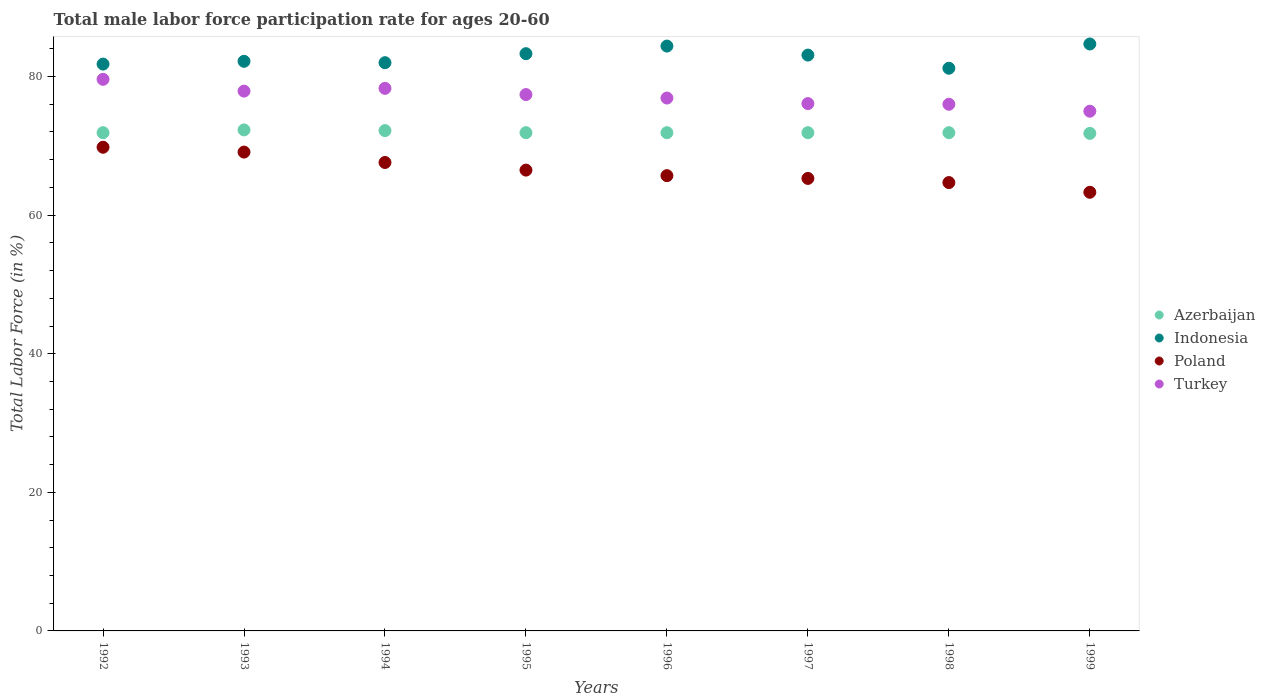What is the male labor force participation rate in Poland in 1994?
Provide a short and direct response. 67.6. Across all years, what is the maximum male labor force participation rate in Poland?
Provide a succinct answer. 69.8. Across all years, what is the minimum male labor force participation rate in Azerbaijan?
Your answer should be very brief. 71.8. In which year was the male labor force participation rate in Indonesia maximum?
Give a very brief answer. 1999. What is the total male labor force participation rate in Poland in the graph?
Ensure brevity in your answer.  532. What is the difference between the male labor force participation rate in Poland in 1994 and that in 1997?
Give a very brief answer. 2.3. What is the difference between the male labor force participation rate in Indonesia in 1997 and the male labor force participation rate in Poland in 1996?
Provide a succinct answer. 17.4. What is the average male labor force participation rate in Poland per year?
Provide a short and direct response. 66.5. In the year 1998, what is the difference between the male labor force participation rate in Indonesia and male labor force participation rate in Azerbaijan?
Your answer should be very brief. 9.3. What is the ratio of the male labor force participation rate in Turkey in 1994 to that in 1995?
Your answer should be compact. 1.01. Is the difference between the male labor force participation rate in Indonesia in 1994 and 1997 greater than the difference between the male labor force participation rate in Azerbaijan in 1994 and 1997?
Give a very brief answer. No. What is the difference between the highest and the second highest male labor force participation rate in Poland?
Make the answer very short. 0.7. What is the difference between the highest and the lowest male labor force participation rate in Poland?
Your answer should be very brief. 6.5. In how many years, is the male labor force participation rate in Poland greater than the average male labor force participation rate in Poland taken over all years?
Give a very brief answer. 4. Is the sum of the male labor force participation rate in Azerbaijan in 1994 and 1995 greater than the maximum male labor force participation rate in Indonesia across all years?
Provide a succinct answer. Yes. Is it the case that in every year, the sum of the male labor force participation rate in Indonesia and male labor force participation rate in Turkey  is greater than the male labor force participation rate in Poland?
Offer a terse response. Yes. Is the male labor force participation rate in Poland strictly less than the male labor force participation rate in Turkey over the years?
Give a very brief answer. Yes. How many dotlines are there?
Provide a succinct answer. 4. How many years are there in the graph?
Offer a terse response. 8. What is the difference between two consecutive major ticks on the Y-axis?
Keep it short and to the point. 20. Does the graph contain any zero values?
Provide a short and direct response. No. How are the legend labels stacked?
Offer a very short reply. Vertical. What is the title of the graph?
Offer a very short reply. Total male labor force participation rate for ages 20-60. What is the Total Labor Force (in %) in Azerbaijan in 1992?
Your response must be concise. 71.9. What is the Total Labor Force (in %) of Indonesia in 1992?
Provide a short and direct response. 81.8. What is the Total Labor Force (in %) in Poland in 1992?
Your answer should be very brief. 69.8. What is the Total Labor Force (in %) of Turkey in 1992?
Your answer should be compact. 79.6. What is the Total Labor Force (in %) in Azerbaijan in 1993?
Keep it short and to the point. 72.3. What is the Total Labor Force (in %) in Indonesia in 1993?
Your answer should be compact. 82.2. What is the Total Labor Force (in %) in Poland in 1993?
Ensure brevity in your answer.  69.1. What is the Total Labor Force (in %) of Turkey in 1993?
Provide a short and direct response. 77.9. What is the Total Labor Force (in %) in Azerbaijan in 1994?
Offer a terse response. 72.2. What is the Total Labor Force (in %) of Indonesia in 1994?
Offer a very short reply. 82. What is the Total Labor Force (in %) of Poland in 1994?
Provide a short and direct response. 67.6. What is the Total Labor Force (in %) in Turkey in 1994?
Offer a very short reply. 78.3. What is the Total Labor Force (in %) of Azerbaijan in 1995?
Offer a terse response. 71.9. What is the Total Labor Force (in %) in Indonesia in 1995?
Ensure brevity in your answer.  83.3. What is the Total Labor Force (in %) in Poland in 1995?
Your answer should be compact. 66.5. What is the Total Labor Force (in %) of Turkey in 1995?
Your answer should be very brief. 77.4. What is the Total Labor Force (in %) in Azerbaijan in 1996?
Offer a terse response. 71.9. What is the Total Labor Force (in %) of Indonesia in 1996?
Keep it short and to the point. 84.4. What is the Total Labor Force (in %) in Poland in 1996?
Keep it short and to the point. 65.7. What is the Total Labor Force (in %) in Turkey in 1996?
Ensure brevity in your answer.  76.9. What is the Total Labor Force (in %) in Azerbaijan in 1997?
Your answer should be very brief. 71.9. What is the Total Labor Force (in %) of Indonesia in 1997?
Keep it short and to the point. 83.1. What is the Total Labor Force (in %) of Poland in 1997?
Make the answer very short. 65.3. What is the Total Labor Force (in %) of Turkey in 1997?
Ensure brevity in your answer.  76.1. What is the Total Labor Force (in %) in Azerbaijan in 1998?
Make the answer very short. 71.9. What is the Total Labor Force (in %) of Indonesia in 1998?
Make the answer very short. 81.2. What is the Total Labor Force (in %) of Poland in 1998?
Ensure brevity in your answer.  64.7. What is the Total Labor Force (in %) of Turkey in 1998?
Offer a very short reply. 76. What is the Total Labor Force (in %) of Azerbaijan in 1999?
Make the answer very short. 71.8. What is the Total Labor Force (in %) of Indonesia in 1999?
Make the answer very short. 84.7. What is the Total Labor Force (in %) in Poland in 1999?
Make the answer very short. 63.3. Across all years, what is the maximum Total Labor Force (in %) in Azerbaijan?
Provide a short and direct response. 72.3. Across all years, what is the maximum Total Labor Force (in %) of Indonesia?
Make the answer very short. 84.7. Across all years, what is the maximum Total Labor Force (in %) of Poland?
Provide a succinct answer. 69.8. Across all years, what is the maximum Total Labor Force (in %) in Turkey?
Make the answer very short. 79.6. Across all years, what is the minimum Total Labor Force (in %) in Azerbaijan?
Provide a succinct answer. 71.8. Across all years, what is the minimum Total Labor Force (in %) of Indonesia?
Provide a succinct answer. 81.2. Across all years, what is the minimum Total Labor Force (in %) in Poland?
Provide a succinct answer. 63.3. What is the total Total Labor Force (in %) in Azerbaijan in the graph?
Ensure brevity in your answer.  575.8. What is the total Total Labor Force (in %) of Indonesia in the graph?
Keep it short and to the point. 662.7. What is the total Total Labor Force (in %) in Poland in the graph?
Provide a succinct answer. 532. What is the total Total Labor Force (in %) in Turkey in the graph?
Ensure brevity in your answer.  617.2. What is the difference between the Total Labor Force (in %) of Poland in 1992 and that in 1993?
Offer a very short reply. 0.7. What is the difference between the Total Labor Force (in %) in Turkey in 1992 and that in 1997?
Give a very brief answer. 3.5. What is the difference between the Total Labor Force (in %) of Azerbaijan in 1992 and that in 1998?
Your answer should be very brief. 0. What is the difference between the Total Labor Force (in %) in Poland in 1992 and that in 1998?
Offer a terse response. 5.1. What is the difference between the Total Labor Force (in %) of Azerbaijan in 1992 and that in 1999?
Make the answer very short. 0.1. What is the difference between the Total Labor Force (in %) in Indonesia in 1992 and that in 1999?
Your answer should be very brief. -2.9. What is the difference between the Total Labor Force (in %) of Poland in 1992 and that in 1999?
Give a very brief answer. 6.5. What is the difference between the Total Labor Force (in %) of Poland in 1993 and that in 1994?
Provide a short and direct response. 1.5. What is the difference between the Total Labor Force (in %) in Indonesia in 1993 and that in 1995?
Your answer should be compact. -1.1. What is the difference between the Total Labor Force (in %) of Indonesia in 1993 and that in 1996?
Your answer should be very brief. -2.2. What is the difference between the Total Labor Force (in %) in Poland in 1993 and that in 1996?
Ensure brevity in your answer.  3.4. What is the difference between the Total Labor Force (in %) in Turkey in 1993 and that in 1996?
Provide a succinct answer. 1. What is the difference between the Total Labor Force (in %) of Indonesia in 1993 and that in 1997?
Provide a short and direct response. -0.9. What is the difference between the Total Labor Force (in %) of Turkey in 1993 and that in 1997?
Offer a terse response. 1.8. What is the difference between the Total Labor Force (in %) in Indonesia in 1993 and that in 1998?
Provide a succinct answer. 1. What is the difference between the Total Labor Force (in %) of Poland in 1993 and that in 1998?
Your answer should be very brief. 4.4. What is the difference between the Total Labor Force (in %) of Turkey in 1993 and that in 1998?
Make the answer very short. 1.9. What is the difference between the Total Labor Force (in %) of Azerbaijan in 1993 and that in 1999?
Offer a terse response. 0.5. What is the difference between the Total Labor Force (in %) of Indonesia in 1993 and that in 1999?
Make the answer very short. -2.5. What is the difference between the Total Labor Force (in %) in Poland in 1993 and that in 1999?
Offer a terse response. 5.8. What is the difference between the Total Labor Force (in %) of Azerbaijan in 1994 and that in 1995?
Give a very brief answer. 0.3. What is the difference between the Total Labor Force (in %) of Indonesia in 1994 and that in 1995?
Provide a short and direct response. -1.3. What is the difference between the Total Labor Force (in %) in Turkey in 1994 and that in 1995?
Your answer should be compact. 0.9. What is the difference between the Total Labor Force (in %) of Azerbaijan in 1994 and that in 1996?
Provide a succinct answer. 0.3. What is the difference between the Total Labor Force (in %) in Poland in 1994 and that in 1996?
Provide a short and direct response. 1.9. What is the difference between the Total Labor Force (in %) in Azerbaijan in 1994 and that in 1997?
Keep it short and to the point. 0.3. What is the difference between the Total Labor Force (in %) of Poland in 1994 and that in 1997?
Make the answer very short. 2.3. What is the difference between the Total Labor Force (in %) in Turkey in 1994 and that in 1997?
Your answer should be compact. 2.2. What is the difference between the Total Labor Force (in %) of Azerbaijan in 1994 and that in 1998?
Provide a short and direct response. 0.3. What is the difference between the Total Labor Force (in %) in Poland in 1994 and that in 1998?
Provide a succinct answer. 2.9. What is the difference between the Total Labor Force (in %) of Indonesia in 1994 and that in 1999?
Give a very brief answer. -2.7. What is the difference between the Total Labor Force (in %) of Indonesia in 1995 and that in 1996?
Provide a short and direct response. -1.1. What is the difference between the Total Labor Force (in %) of Poland in 1995 and that in 1996?
Give a very brief answer. 0.8. What is the difference between the Total Labor Force (in %) in Turkey in 1995 and that in 1996?
Make the answer very short. 0.5. What is the difference between the Total Labor Force (in %) in Azerbaijan in 1995 and that in 1997?
Offer a very short reply. 0. What is the difference between the Total Labor Force (in %) in Indonesia in 1995 and that in 1997?
Your answer should be compact. 0.2. What is the difference between the Total Labor Force (in %) of Azerbaijan in 1995 and that in 1998?
Make the answer very short. 0. What is the difference between the Total Labor Force (in %) in Indonesia in 1995 and that in 1999?
Make the answer very short. -1.4. What is the difference between the Total Labor Force (in %) of Indonesia in 1996 and that in 1997?
Make the answer very short. 1.3. What is the difference between the Total Labor Force (in %) in Poland in 1996 and that in 1997?
Make the answer very short. 0.4. What is the difference between the Total Labor Force (in %) of Indonesia in 1996 and that in 1998?
Provide a short and direct response. 3.2. What is the difference between the Total Labor Force (in %) in Poland in 1996 and that in 1999?
Provide a succinct answer. 2.4. What is the difference between the Total Labor Force (in %) of Poland in 1997 and that in 1998?
Make the answer very short. 0.6. What is the difference between the Total Labor Force (in %) of Azerbaijan in 1997 and that in 1999?
Your answer should be very brief. 0.1. What is the difference between the Total Labor Force (in %) of Poland in 1997 and that in 1999?
Offer a very short reply. 2. What is the difference between the Total Labor Force (in %) in Turkey in 1997 and that in 1999?
Provide a succinct answer. 1.1. What is the difference between the Total Labor Force (in %) of Azerbaijan in 1998 and that in 1999?
Your answer should be very brief. 0.1. What is the difference between the Total Labor Force (in %) of Poland in 1998 and that in 1999?
Your response must be concise. 1.4. What is the difference between the Total Labor Force (in %) of Turkey in 1998 and that in 1999?
Make the answer very short. 1. What is the difference between the Total Labor Force (in %) in Azerbaijan in 1992 and the Total Labor Force (in %) in Indonesia in 1993?
Keep it short and to the point. -10.3. What is the difference between the Total Labor Force (in %) of Azerbaijan in 1992 and the Total Labor Force (in %) of Poland in 1993?
Offer a very short reply. 2.8. What is the difference between the Total Labor Force (in %) of Azerbaijan in 1992 and the Total Labor Force (in %) of Turkey in 1993?
Offer a very short reply. -6. What is the difference between the Total Labor Force (in %) of Indonesia in 1992 and the Total Labor Force (in %) of Turkey in 1994?
Make the answer very short. 3.5. What is the difference between the Total Labor Force (in %) of Poland in 1992 and the Total Labor Force (in %) of Turkey in 1994?
Offer a very short reply. -8.5. What is the difference between the Total Labor Force (in %) of Azerbaijan in 1992 and the Total Labor Force (in %) of Indonesia in 1995?
Your response must be concise. -11.4. What is the difference between the Total Labor Force (in %) of Azerbaijan in 1992 and the Total Labor Force (in %) of Poland in 1995?
Ensure brevity in your answer.  5.4. What is the difference between the Total Labor Force (in %) of Azerbaijan in 1992 and the Total Labor Force (in %) of Turkey in 1995?
Your answer should be compact. -5.5. What is the difference between the Total Labor Force (in %) in Indonesia in 1992 and the Total Labor Force (in %) in Poland in 1995?
Keep it short and to the point. 15.3. What is the difference between the Total Labor Force (in %) of Azerbaijan in 1992 and the Total Labor Force (in %) of Indonesia in 1996?
Your answer should be very brief. -12.5. What is the difference between the Total Labor Force (in %) of Azerbaijan in 1992 and the Total Labor Force (in %) of Turkey in 1996?
Give a very brief answer. -5. What is the difference between the Total Labor Force (in %) of Indonesia in 1992 and the Total Labor Force (in %) of Poland in 1996?
Give a very brief answer. 16.1. What is the difference between the Total Labor Force (in %) of Indonesia in 1992 and the Total Labor Force (in %) of Turkey in 1996?
Offer a very short reply. 4.9. What is the difference between the Total Labor Force (in %) in Poland in 1992 and the Total Labor Force (in %) in Turkey in 1996?
Offer a very short reply. -7.1. What is the difference between the Total Labor Force (in %) of Azerbaijan in 1992 and the Total Labor Force (in %) of Poland in 1997?
Make the answer very short. 6.6. What is the difference between the Total Labor Force (in %) of Azerbaijan in 1992 and the Total Labor Force (in %) of Indonesia in 1998?
Offer a terse response. -9.3. What is the difference between the Total Labor Force (in %) of Azerbaijan in 1992 and the Total Labor Force (in %) of Turkey in 1998?
Your answer should be compact. -4.1. What is the difference between the Total Labor Force (in %) of Indonesia in 1992 and the Total Labor Force (in %) of Turkey in 1998?
Provide a succinct answer. 5.8. What is the difference between the Total Labor Force (in %) of Poland in 1992 and the Total Labor Force (in %) of Turkey in 1998?
Give a very brief answer. -6.2. What is the difference between the Total Labor Force (in %) in Azerbaijan in 1992 and the Total Labor Force (in %) in Poland in 1999?
Keep it short and to the point. 8.6. What is the difference between the Total Labor Force (in %) in Azerbaijan in 1992 and the Total Labor Force (in %) in Turkey in 1999?
Ensure brevity in your answer.  -3.1. What is the difference between the Total Labor Force (in %) of Azerbaijan in 1993 and the Total Labor Force (in %) of Indonesia in 1994?
Your answer should be compact. -9.7. What is the difference between the Total Labor Force (in %) of Indonesia in 1993 and the Total Labor Force (in %) of Turkey in 1994?
Your response must be concise. 3.9. What is the difference between the Total Labor Force (in %) in Poland in 1993 and the Total Labor Force (in %) in Turkey in 1994?
Offer a terse response. -9.2. What is the difference between the Total Labor Force (in %) of Azerbaijan in 1993 and the Total Labor Force (in %) of Indonesia in 1995?
Ensure brevity in your answer.  -11. What is the difference between the Total Labor Force (in %) in Azerbaijan in 1993 and the Total Labor Force (in %) in Poland in 1995?
Your answer should be very brief. 5.8. What is the difference between the Total Labor Force (in %) of Poland in 1993 and the Total Labor Force (in %) of Turkey in 1995?
Ensure brevity in your answer.  -8.3. What is the difference between the Total Labor Force (in %) in Azerbaijan in 1993 and the Total Labor Force (in %) in Indonesia in 1996?
Keep it short and to the point. -12.1. What is the difference between the Total Labor Force (in %) of Azerbaijan in 1993 and the Total Labor Force (in %) of Turkey in 1996?
Offer a terse response. -4.6. What is the difference between the Total Labor Force (in %) of Poland in 1993 and the Total Labor Force (in %) of Turkey in 1996?
Give a very brief answer. -7.8. What is the difference between the Total Labor Force (in %) of Azerbaijan in 1993 and the Total Labor Force (in %) of Turkey in 1997?
Offer a very short reply. -3.8. What is the difference between the Total Labor Force (in %) of Indonesia in 1993 and the Total Labor Force (in %) of Poland in 1997?
Ensure brevity in your answer.  16.9. What is the difference between the Total Labor Force (in %) of Indonesia in 1993 and the Total Labor Force (in %) of Turkey in 1997?
Keep it short and to the point. 6.1. What is the difference between the Total Labor Force (in %) of Azerbaijan in 1993 and the Total Labor Force (in %) of Indonesia in 1998?
Give a very brief answer. -8.9. What is the difference between the Total Labor Force (in %) of Azerbaijan in 1993 and the Total Labor Force (in %) of Turkey in 1998?
Keep it short and to the point. -3.7. What is the difference between the Total Labor Force (in %) in Indonesia in 1993 and the Total Labor Force (in %) in Poland in 1998?
Make the answer very short. 17.5. What is the difference between the Total Labor Force (in %) in Poland in 1993 and the Total Labor Force (in %) in Turkey in 1998?
Your answer should be very brief. -6.9. What is the difference between the Total Labor Force (in %) of Azerbaijan in 1993 and the Total Labor Force (in %) of Poland in 1999?
Your answer should be compact. 9. What is the difference between the Total Labor Force (in %) in Azerbaijan in 1993 and the Total Labor Force (in %) in Turkey in 1999?
Offer a terse response. -2.7. What is the difference between the Total Labor Force (in %) in Indonesia in 1993 and the Total Labor Force (in %) in Turkey in 1999?
Keep it short and to the point. 7.2. What is the difference between the Total Labor Force (in %) in Azerbaijan in 1994 and the Total Labor Force (in %) in Indonesia in 1995?
Offer a terse response. -11.1. What is the difference between the Total Labor Force (in %) of Azerbaijan in 1994 and the Total Labor Force (in %) of Turkey in 1995?
Offer a very short reply. -5.2. What is the difference between the Total Labor Force (in %) of Indonesia in 1994 and the Total Labor Force (in %) of Poland in 1995?
Keep it short and to the point. 15.5. What is the difference between the Total Labor Force (in %) in Indonesia in 1994 and the Total Labor Force (in %) in Turkey in 1995?
Your response must be concise. 4.6. What is the difference between the Total Labor Force (in %) of Poland in 1994 and the Total Labor Force (in %) of Turkey in 1995?
Make the answer very short. -9.8. What is the difference between the Total Labor Force (in %) of Azerbaijan in 1994 and the Total Labor Force (in %) of Indonesia in 1996?
Your answer should be compact. -12.2. What is the difference between the Total Labor Force (in %) in Poland in 1994 and the Total Labor Force (in %) in Turkey in 1996?
Offer a terse response. -9.3. What is the difference between the Total Labor Force (in %) in Azerbaijan in 1994 and the Total Labor Force (in %) in Poland in 1997?
Make the answer very short. 6.9. What is the difference between the Total Labor Force (in %) of Azerbaijan in 1994 and the Total Labor Force (in %) of Indonesia in 1998?
Make the answer very short. -9. What is the difference between the Total Labor Force (in %) in Azerbaijan in 1994 and the Total Labor Force (in %) in Poland in 1998?
Provide a short and direct response. 7.5. What is the difference between the Total Labor Force (in %) in Azerbaijan in 1994 and the Total Labor Force (in %) in Turkey in 1998?
Provide a succinct answer. -3.8. What is the difference between the Total Labor Force (in %) in Indonesia in 1994 and the Total Labor Force (in %) in Turkey in 1998?
Your answer should be compact. 6. What is the difference between the Total Labor Force (in %) in Azerbaijan in 1994 and the Total Labor Force (in %) in Indonesia in 1999?
Give a very brief answer. -12.5. What is the difference between the Total Labor Force (in %) in Azerbaijan in 1994 and the Total Labor Force (in %) in Poland in 1999?
Keep it short and to the point. 8.9. What is the difference between the Total Labor Force (in %) of Azerbaijan in 1994 and the Total Labor Force (in %) of Turkey in 1999?
Give a very brief answer. -2.8. What is the difference between the Total Labor Force (in %) in Indonesia in 1994 and the Total Labor Force (in %) in Poland in 1999?
Provide a short and direct response. 18.7. What is the difference between the Total Labor Force (in %) in Indonesia in 1994 and the Total Labor Force (in %) in Turkey in 1999?
Your answer should be compact. 7. What is the difference between the Total Labor Force (in %) in Azerbaijan in 1995 and the Total Labor Force (in %) in Turkey in 1996?
Provide a succinct answer. -5. What is the difference between the Total Labor Force (in %) of Indonesia in 1995 and the Total Labor Force (in %) of Turkey in 1996?
Give a very brief answer. 6.4. What is the difference between the Total Labor Force (in %) in Azerbaijan in 1995 and the Total Labor Force (in %) in Turkey in 1997?
Make the answer very short. -4.2. What is the difference between the Total Labor Force (in %) in Indonesia in 1995 and the Total Labor Force (in %) in Poland in 1997?
Keep it short and to the point. 18. What is the difference between the Total Labor Force (in %) of Indonesia in 1995 and the Total Labor Force (in %) of Turkey in 1997?
Ensure brevity in your answer.  7.2. What is the difference between the Total Labor Force (in %) in Azerbaijan in 1995 and the Total Labor Force (in %) in Poland in 1998?
Make the answer very short. 7.2. What is the difference between the Total Labor Force (in %) of Azerbaijan in 1995 and the Total Labor Force (in %) of Poland in 1999?
Provide a short and direct response. 8.6. What is the difference between the Total Labor Force (in %) of Azerbaijan in 1995 and the Total Labor Force (in %) of Turkey in 1999?
Provide a short and direct response. -3.1. What is the difference between the Total Labor Force (in %) in Indonesia in 1995 and the Total Labor Force (in %) in Turkey in 1999?
Keep it short and to the point. 8.3. What is the difference between the Total Labor Force (in %) in Azerbaijan in 1996 and the Total Labor Force (in %) in Indonesia in 1997?
Make the answer very short. -11.2. What is the difference between the Total Labor Force (in %) of Azerbaijan in 1996 and the Total Labor Force (in %) of Poland in 1997?
Provide a short and direct response. 6.6. What is the difference between the Total Labor Force (in %) of Indonesia in 1996 and the Total Labor Force (in %) of Turkey in 1997?
Give a very brief answer. 8.3. What is the difference between the Total Labor Force (in %) of Poland in 1996 and the Total Labor Force (in %) of Turkey in 1997?
Provide a succinct answer. -10.4. What is the difference between the Total Labor Force (in %) in Azerbaijan in 1996 and the Total Labor Force (in %) in Indonesia in 1998?
Ensure brevity in your answer.  -9.3. What is the difference between the Total Labor Force (in %) in Indonesia in 1996 and the Total Labor Force (in %) in Poland in 1998?
Make the answer very short. 19.7. What is the difference between the Total Labor Force (in %) in Indonesia in 1996 and the Total Labor Force (in %) in Turkey in 1998?
Offer a very short reply. 8.4. What is the difference between the Total Labor Force (in %) in Poland in 1996 and the Total Labor Force (in %) in Turkey in 1998?
Make the answer very short. -10.3. What is the difference between the Total Labor Force (in %) of Azerbaijan in 1996 and the Total Labor Force (in %) of Poland in 1999?
Ensure brevity in your answer.  8.6. What is the difference between the Total Labor Force (in %) in Indonesia in 1996 and the Total Labor Force (in %) in Poland in 1999?
Your answer should be very brief. 21.1. What is the difference between the Total Labor Force (in %) in Indonesia in 1996 and the Total Labor Force (in %) in Turkey in 1999?
Make the answer very short. 9.4. What is the difference between the Total Labor Force (in %) in Azerbaijan in 1997 and the Total Labor Force (in %) in Poland in 1998?
Provide a short and direct response. 7.2. What is the difference between the Total Labor Force (in %) of Azerbaijan in 1997 and the Total Labor Force (in %) of Turkey in 1998?
Keep it short and to the point. -4.1. What is the difference between the Total Labor Force (in %) in Indonesia in 1997 and the Total Labor Force (in %) in Turkey in 1998?
Provide a succinct answer. 7.1. What is the difference between the Total Labor Force (in %) in Poland in 1997 and the Total Labor Force (in %) in Turkey in 1998?
Your response must be concise. -10.7. What is the difference between the Total Labor Force (in %) in Azerbaijan in 1997 and the Total Labor Force (in %) in Poland in 1999?
Ensure brevity in your answer.  8.6. What is the difference between the Total Labor Force (in %) of Indonesia in 1997 and the Total Labor Force (in %) of Poland in 1999?
Provide a succinct answer. 19.8. What is the difference between the Total Labor Force (in %) of Poland in 1997 and the Total Labor Force (in %) of Turkey in 1999?
Ensure brevity in your answer.  -9.7. What is the difference between the Total Labor Force (in %) of Indonesia in 1998 and the Total Labor Force (in %) of Turkey in 1999?
Keep it short and to the point. 6.2. What is the difference between the Total Labor Force (in %) in Poland in 1998 and the Total Labor Force (in %) in Turkey in 1999?
Your answer should be compact. -10.3. What is the average Total Labor Force (in %) in Azerbaijan per year?
Your answer should be very brief. 71.97. What is the average Total Labor Force (in %) of Indonesia per year?
Ensure brevity in your answer.  82.84. What is the average Total Labor Force (in %) in Poland per year?
Your answer should be compact. 66.5. What is the average Total Labor Force (in %) in Turkey per year?
Provide a short and direct response. 77.15. In the year 1992, what is the difference between the Total Labor Force (in %) of Azerbaijan and Total Labor Force (in %) of Indonesia?
Provide a succinct answer. -9.9. In the year 1992, what is the difference between the Total Labor Force (in %) of Azerbaijan and Total Labor Force (in %) of Turkey?
Offer a very short reply. -7.7. In the year 1992, what is the difference between the Total Labor Force (in %) in Indonesia and Total Labor Force (in %) in Turkey?
Keep it short and to the point. 2.2. In the year 1993, what is the difference between the Total Labor Force (in %) in Azerbaijan and Total Labor Force (in %) in Poland?
Give a very brief answer. 3.2. In the year 1993, what is the difference between the Total Labor Force (in %) of Azerbaijan and Total Labor Force (in %) of Turkey?
Make the answer very short. -5.6. In the year 1993, what is the difference between the Total Labor Force (in %) in Indonesia and Total Labor Force (in %) in Turkey?
Ensure brevity in your answer.  4.3. In the year 1994, what is the difference between the Total Labor Force (in %) in Azerbaijan and Total Labor Force (in %) in Turkey?
Provide a short and direct response. -6.1. In the year 1994, what is the difference between the Total Labor Force (in %) in Indonesia and Total Labor Force (in %) in Turkey?
Provide a succinct answer. 3.7. In the year 1994, what is the difference between the Total Labor Force (in %) in Poland and Total Labor Force (in %) in Turkey?
Ensure brevity in your answer.  -10.7. In the year 1995, what is the difference between the Total Labor Force (in %) of Indonesia and Total Labor Force (in %) of Poland?
Make the answer very short. 16.8. In the year 1996, what is the difference between the Total Labor Force (in %) in Azerbaijan and Total Labor Force (in %) in Indonesia?
Offer a terse response. -12.5. In the year 1996, what is the difference between the Total Labor Force (in %) of Azerbaijan and Total Labor Force (in %) of Poland?
Make the answer very short. 6.2. In the year 1996, what is the difference between the Total Labor Force (in %) of Poland and Total Labor Force (in %) of Turkey?
Provide a succinct answer. -11.2. In the year 1997, what is the difference between the Total Labor Force (in %) in Azerbaijan and Total Labor Force (in %) in Turkey?
Your answer should be compact. -4.2. In the year 1997, what is the difference between the Total Labor Force (in %) of Indonesia and Total Labor Force (in %) of Turkey?
Provide a short and direct response. 7. In the year 1997, what is the difference between the Total Labor Force (in %) in Poland and Total Labor Force (in %) in Turkey?
Offer a very short reply. -10.8. In the year 1998, what is the difference between the Total Labor Force (in %) in Azerbaijan and Total Labor Force (in %) in Indonesia?
Your response must be concise. -9.3. In the year 1998, what is the difference between the Total Labor Force (in %) in Azerbaijan and Total Labor Force (in %) in Turkey?
Ensure brevity in your answer.  -4.1. In the year 1998, what is the difference between the Total Labor Force (in %) in Poland and Total Labor Force (in %) in Turkey?
Keep it short and to the point. -11.3. In the year 1999, what is the difference between the Total Labor Force (in %) of Azerbaijan and Total Labor Force (in %) of Indonesia?
Provide a short and direct response. -12.9. In the year 1999, what is the difference between the Total Labor Force (in %) in Indonesia and Total Labor Force (in %) in Poland?
Provide a short and direct response. 21.4. In the year 1999, what is the difference between the Total Labor Force (in %) of Indonesia and Total Labor Force (in %) of Turkey?
Ensure brevity in your answer.  9.7. What is the ratio of the Total Labor Force (in %) in Turkey in 1992 to that in 1993?
Provide a short and direct response. 1.02. What is the ratio of the Total Labor Force (in %) in Poland in 1992 to that in 1994?
Your answer should be compact. 1.03. What is the ratio of the Total Labor Force (in %) in Turkey in 1992 to that in 1994?
Offer a very short reply. 1.02. What is the ratio of the Total Labor Force (in %) of Azerbaijan in 1992 to that in 1995?
Provide a short and direct response. 1. What is the ratio of the Total Labor Force (in %) in Indonesia in 1992 to that in 1995?
Offer a terse response. 0.98. What is the ratio of the Total Labor Force (in %) of Poland in 1992 to that in 1995?
Provide a succinct answer. 1.05. What is the ratio of the Total Labor Force (in %) of Turkey in 1992 to that in 1995?
Your answer should be very brief. 1.03. What is the ratio of the Total Labor Force (in %) in Indonesia in 1992 to that in 1996?
Provide a short and direct response. 0.97. What is the ratio of the Total Labor Force (in %) of Poland in 1992 to that in 1996?
Give a very brief answer. 1.06. What is the ratio of the Total Labor Force (in %) of Turkey in 1992 to that in 1996?
Your answer should be compact. 1.04. What is the ratio of the Total Labor Force (in %) in Indonesia in 1992 to that in 1997?
Give a very brief answer. 0.98. What is the ratio of the Total Labor Force (in %) in Poland in 1992 to that in 1997?
Your response must be concise. 1.07. What is the ratio of the Total Labor Force (in %) in Turkey in 1992 to that in 1997?
Make the answer very short. 1.05. What is the ratio of the Total Labor Force (in %) in Azerbaijan in 1992 to that in 1998?
Give a very brief answer. 1. What is the ratio of the Total Labor Force (in %) of Indonesia in 1992 to that in 1998?
Your answer should be compact. 1.01. What is the ratio of the Total Labor Force (in %) of Poland in 1992 to that in 1998?
Give a very brief answer. 1.08. What is the ratio of the Total Labor Force (in %) of Turkey in 1992 to that in 1998?
Your answer should be compact. 1.05. What is the ratio of the Total Labor Force (in %) of Indonesia in 1992 to that in 1999?
Make the answer very short. 0.97. What is the ratio of the Total Labor Force (in %) in Poland in 1992 to that in 1999?
Keep it short and to the point. 1.1. What is the ratio of the Total Labor Force (in %) of Turkey in 1992 to that in 1999?
Make the answer very short. 1.06. What is the ratio of the Total Labor Force (in %) of Indonesia in 1993 to that in 1994?
Offer a very short reply. 1. What is the ratio of the Total Labor Force (in %) in Poland in 1993 to that in 1994?
Ensure brevity in your answer.  1.02. What is the ratio of the Total Labor Force (in %) in Turkey in 1993 to that in 1994?
Keep it short and to the point. 0.99. What is the ratio of the Total Labor Force (in %) of Azerbaijan in 1993 to that in 1995?
Keep it short and to the point. 1.01. What is the ratio of the Total Labor Force (in %) in Indonesia in 1993 to that in 1995?
Provide a short and direct response. 0.99. What is the ratio of the Total Labor Force (in %) in Poland in 1993 to that in 1995?
Provide a short and direct response. 1.04. What is the ratio of the Total Labor Force (in %) in Azerbaijan in 1993 to that in 1996?
Your answer should be very brief. 1.01. What is the ratio of the Total Labor Force (in %) of Indonesia in 1993 to that in 1996?
Your answer should be very brief. 0.97. What is the ratio of the Total Labor Force (in %) in Poland in 1993 to that in 1996?
Keep it short and to the point. 1.05. What is the ratio of the Total Labor Force (in %) of Azerbaijan in 1993 to that in 1997?
Provide a short and direct response. 1.01. What is the ratio of the Total Labor Force (in %) in Poland in 1993 to that in 1997?
Your answer should be very brief. 1.06. What is the ratio of the Total Labor Force (in %) in Turkey in 1993 to that in 1997?
Ensure brevity in your answer.  1.02. What is the ratio of the Total Labor Force (in %) of Azerbaijan in 1993 to that in 1998?
Your response must be concise. 1.01. What is the ratio of the Total Labor Force (in %) in Indonesia in 1993 to that in 1998?
Keep it short and to the point. 1.01. What is the ratio of the Total Labor Force (in %) of Poland in 1993 to that in 1998?
Give a very brief answer. 1.07. What is the ratio of the Total Labor Force (in %) in Turkey in 1993 to that in 1998?
Keep it short and to the point. 1.02. What is the ratio of the Total Labor Force (in %) in Azerbaijan in 1993 to that in 1999?
Your response must be concise. 1.01. What is the ratio of the Total Labor Force (in %) in Indonesia in 1993 to that in 1999?
Your answer should be compact. 0.97. What is the ratio of the Total Labor Force (in %) of Poland in 1993 to that in 1999?
Your answer should be very brief. 1.09. What is the ratio of the Total Labor Force (in %) in Turkey in 1993 to that in 1999?
Your response must be concise. 1.04. What is the ratio of the Total Labor Force (in %) of Indonesia in 1994 to that in 1995?
Provide a short and direct response. 0.98. What is the ratio of the Total Labor Force (in %) in Poland in 1994 to that in 1995?
Provide a succinct answer. 1.02. What is the ratio of the Total Labor Force (in %) in Turkey in 1994 to that in 1995?
Provide a short and direct response. 1.01. What is the ratio of the Total Labor Force (in %) of Azerbaijan in 1994 to that in 1996?
Your answer should be compact. 1. What is the ratio of the Total Labor Force (in %) of Indonesia in 1994 to that in 1996?
Your answer should be compact. 0.97. What is the ratio of the Total Labor Force (in %) of Poland in 1994 to that in 1996?
Your answer should be very brief. 1.03. What is the ratio of the Total Labor Force (in %) in Turkey in 1994 to that in 1996?
Your answer should be compact. 1.02. What is the ratio of the Total Labor Force (in %) of Azerbaijan in 1994 to that in 1997?
Offer a terse response. 1. What is the ratio of the Total Labor Force (in %) in Indonesia in 1994 to that in 1997?
Make the answer very short. 0.99. What is the ratio of the Total Labor Force (in %) of Poland in 1994 to that in 1997?
Make the answer very short. 1.04. What is the ratio of the Total Labor Force (in %) in Turkey in 1994 to that in 1997?
Keep it short and to the point. 1.03. What is the ratio of the Total Labor Force (in %) in Azerbaijan in 1994 to that in 1998?
Ensure brevity in your answer.  1. What is the ratio of the Total Labor Force (in %) of Indonesia in 1994 to that in 1998?
Provide a succinct answer. 1.01. What is the ratio of the Total Labor Force (in %) in Poland in 1994 to that in 1998?
Provide a short and direct response. 1.04. What is the ratio of the Total Labor Force (in %) in Turkey in 1994 to that in 1998?
Your response must be concise. 1.03. What is the ratio of the Total Labor Force (in %) in Azerbaijan in 1994 to that in 1999?
Offer a very short reply. 1.01. What is the ratio of the Total Labor Force (in %) of Indonesia in 1994 to that in 1999?
Give a very brief answer. 0.97. What is the ratio of the Total Labor Force (in %) of Poland in 1994 to that in 1999?
Provide a short and direct response. 1.07. What is the ratio of the Total Labor Force (in %) in Turkey in 1994 to that in 1999?
Keep it short and to the point. 1.04. What is the ratio of the Total Labor Force (in %) of Indonesia in 1995 to that in 1996?
Give a very brief answer. 0.99. What is the ratio of the Total Labor Force (in %) in Poland in 1995 to that in 1996?
Offer a very short reply. 1.01. What is the ratio of the Total Labor Force (in %) of Indonesia in 1995 to that in 1997?
Make the answer very short. 1. What is the ratio of the Total Labor Force (in %) of Poland in 1995 to that in 1997?
Provide a short and direct response. 1.02. What is the ratio of the Total Labor Force (in %) of Turkey in 1995 to that in 1997?
Offer a terse response. 1.02. What is the ratio of the Total Labor Force (in %) in Azerbaijan in 1995 to that in 1998?
Keep it short and to the point. 1. What is the ratio of the Total Labor Force (in %) of Indonesia in 1995 to that in 1998?
Offer a very short reply. 1.03. What is the ratio of the Total Labor Force (in %) of Poland in 1995 to that in 1998?
Your response must be concise. 1.03. What is the ratio of the Total Labor Force (in %) of Turkey in 1995 to that in 1998?
Your answer should be compact. 1.02. What is the ratio of the Total Labor Force (in %) of Azerbaijan in 1995 to that in 1999?
Your answer should be very brief. 1. What is the ratio of the Total Labor Force (in %) of Indonesia in 1995 to that in 1999?
Offer a very short reply. 0.98. What is the ratio of the Total Labor Force (in %) of Poland in 1995 to that in 1999?
Give a very brief answer. 1.05. What is the ratio of the Total Labor Force (in %) of Turkey in 1995 to that in 1999?
Provide a short and direct response. 1.03. What is the ratio of the Total Labor Force (in %) in Indonesia in 1996 to that in 1997?
Ensure brevity in your answer.  1.02. What is the ratio of the Total Labor Force (in %) in Poland in 1996 to that in 1997?
Keep it short and to the point. 1.01. What is the ratio of the Total Labor Force (in %) in Turkey in 1996 to that in 1997?
Your response must be concise. 1.01. What is the ratio of the Total Labor Force (in %) in Azerbaijan in 1996 to that in 1998?
Provide a succinct answer. 1. What is the ratio of the Total Labor Force (in %) of Indonesia in 1996 to that in 1998?
Your answer should be compact. 1.04. What is the ratio of the Total Labor Force (in %) in Poland in 1996 to that in 1998?
Provide a succinct answer. 1.02. What is the ratio of the Total Labor Force (in %) in Turkey in 1996 to that in 1998?
Your answer should be very brief. 1.01. What is the ratio of the Total Labor Force (in %) in Azerbaijan in 1996 to that in 1999?
Your answer should be compact. 1. What is the ratio of the Total Labor Force (in %) in Poland in 1996 to that in 1999?
Provide a succinct answer. 1.04. What is the ratio of the Total Labor Force (in %) of Turkey in 1996 to that in 1999?
Provide a succinct answer. 1.03. What is the ratio of the Total Labor Force (in %) of Indonesia in 1997 to that in 1998?
Ensure brevity in your answer.  1.02. What is the ratio of the Total Labor Force (in %) of Poland in 1997 to that in 1998?
Provide a short and direct response. 1.01. What is the ratio of the Total Labor Force (in %) of Turkey in 1997 to that in 1998?
Offer a very short reply. 1. What is the ratio of the Total Labor Force (in %) of Indonesia in 1997 to that in 1999?
Give a very brief answer. 0.98. What is the ratio of the Total Labor Force (in %) of Poland in 1997 to that in 1999?
Keep it short and to the point. 1.03. What is the ratio of the Total Labor Force (in %) in Turkey in 1997 to that in 1999?
Your answer should be very brief. 1.01. What is the ratio of the Total Labor Force (in %) of Azerbaijan in 1998 to that in 1999?
Provide a short and direct response. 1. What is the ratio of the Total Labor Force (in %) of Indonesia in 1998 to that in 1999?
Your answer should be compact. 0.96. What is the ratio of the Total Labor Force (in %) of Poland in 1998 to that in 1999?
Ensure brevity in your answer.  1.02. What is the ratio of the Total Labor Force (in %) in Turkey in 1998 to that in 1999?
Provide a succinct answer. 1.01. What is the difference between the highest and the lowest Total Labor Force (in %) of Azerbaijan?
Offer a very short reply. 0.5. What is the difference between the highest and the lowest Total Labor Force (in %) in Poland?
Your answer should be very brief. 6.5. 